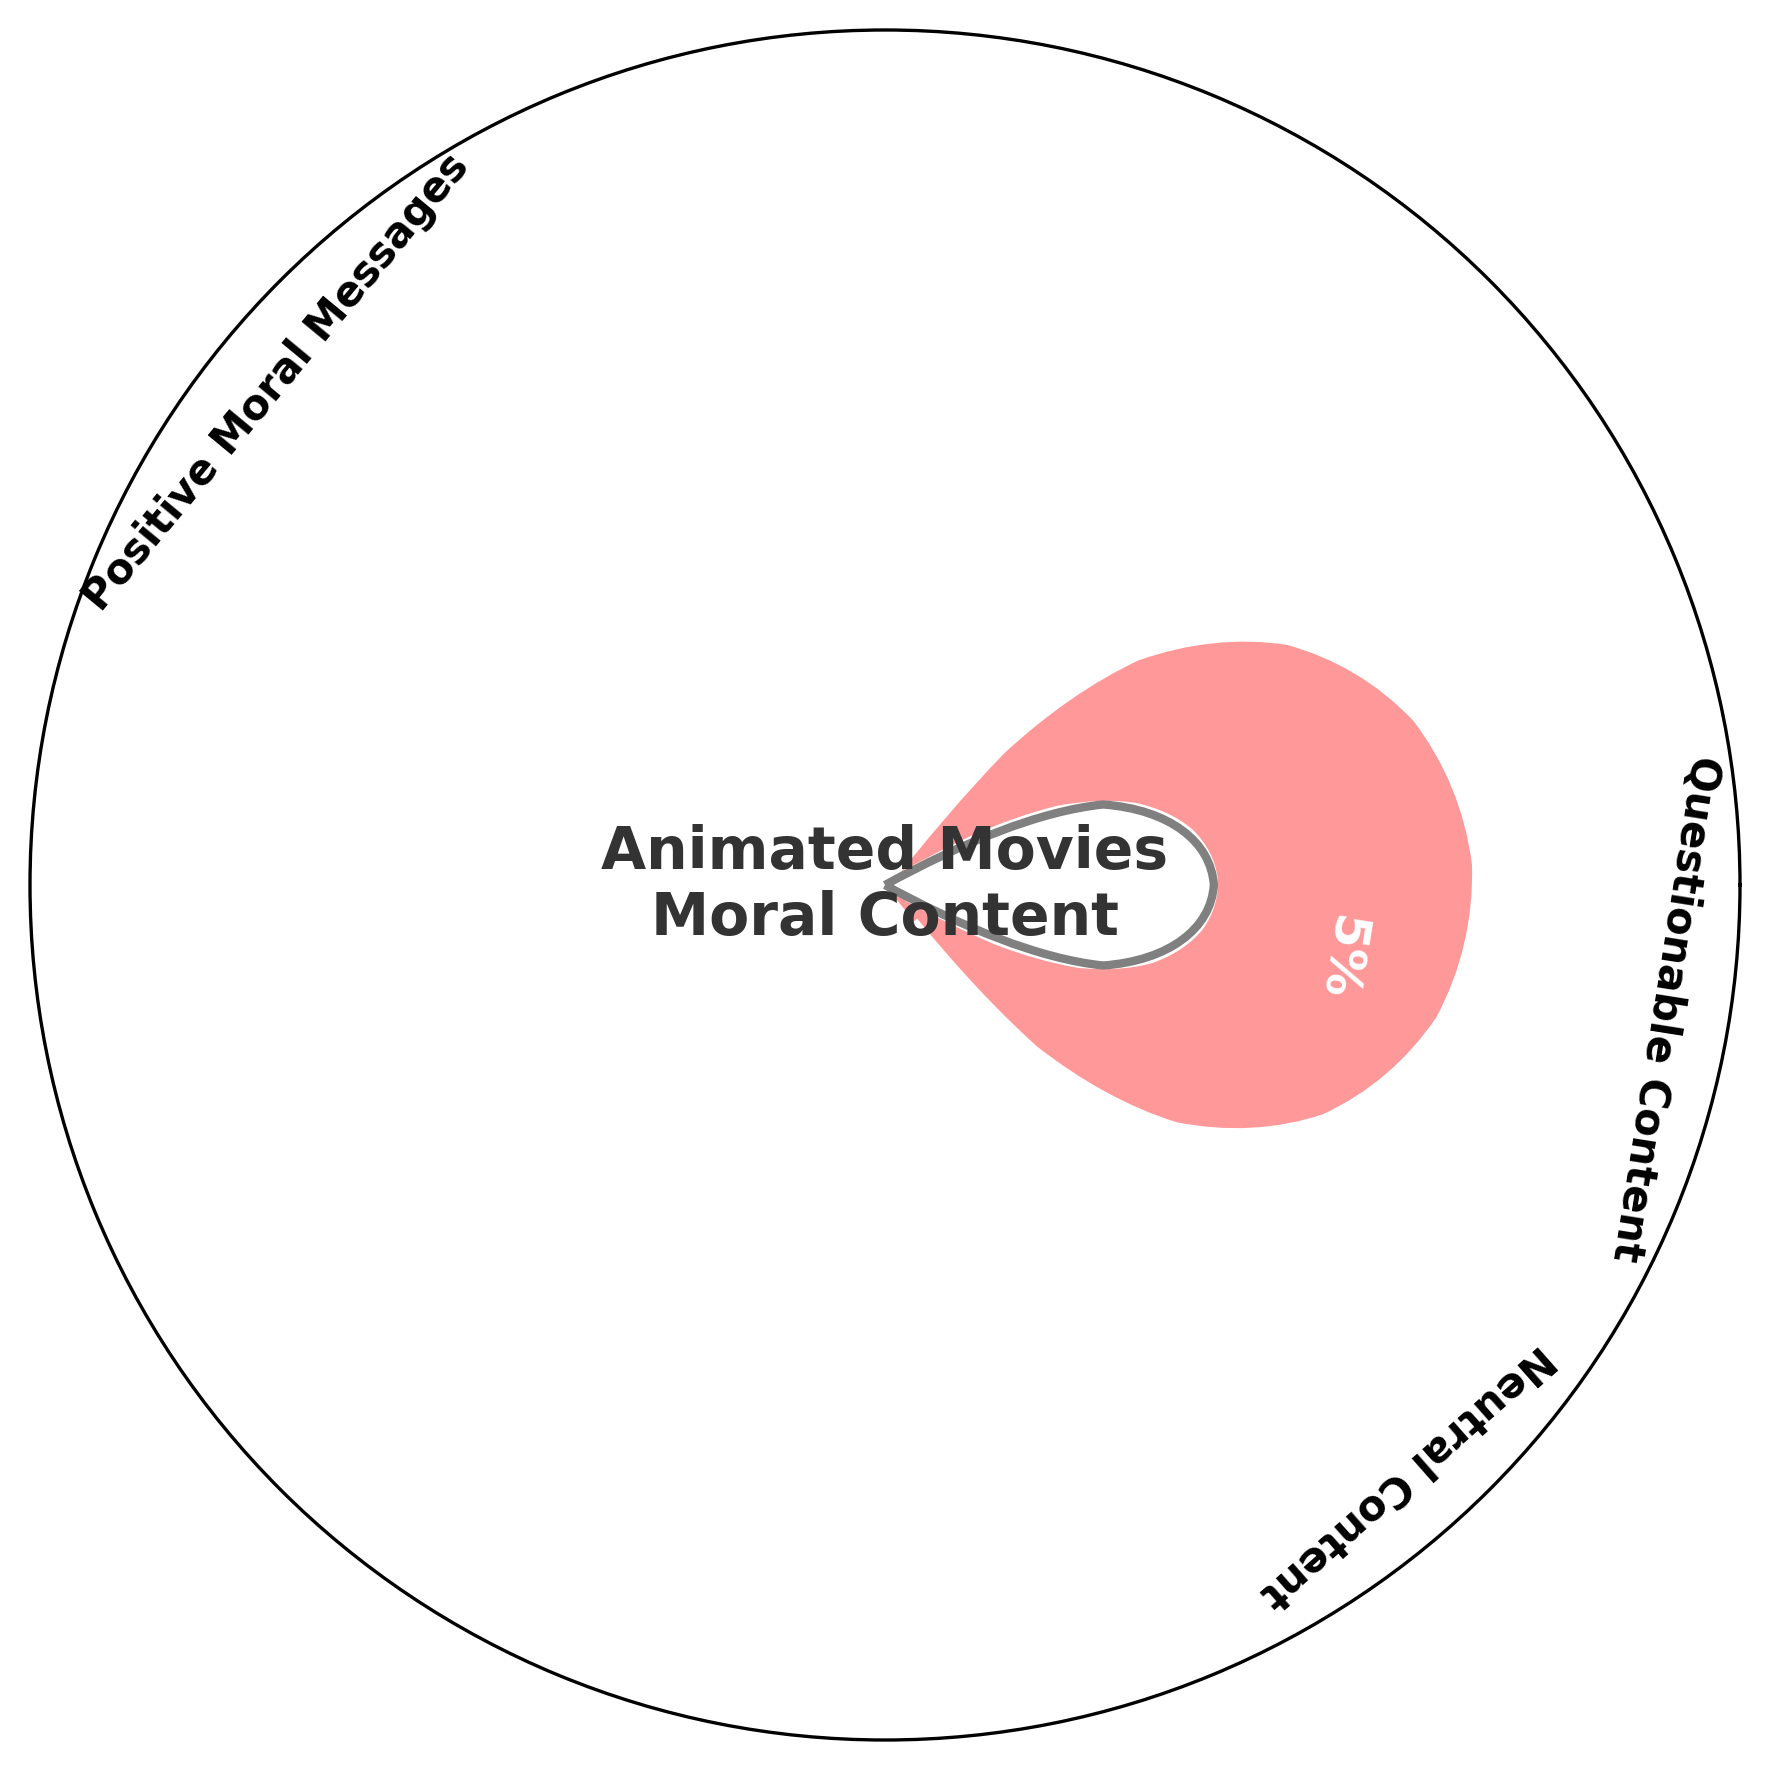What percentage of animated movies released in the last year had positive moral messages? The gauge chart clearly shows that 78% of the animated movies released in the last year had positive moral messages.
Answer: 78% What category had the least percentage of animated movies released in the last year? The gauge chart shows three categories, with the "Questionable Content" segment being the smallest at 5%.
Answer: Questionable Content How do the percentages of animated movies with neutral content and questionable content compare? The gauge chart indicates that neutral content makes up 17%, while questionable content makes up 5%. Comparing these percentages, 17% is greater than 5%.
Answer: Neutral Content > Questionable Content What is the total percentage of animated movies released last year that did not have positive moral messages? To find this, sum the percentages of "Neutral Content" and "Questionable Content" which are 17% and 5% respectively. So, 17% + 5% = 22%.
Answer: 22% What is the angle in the gauge chart for the "Neutral Content" category? The angle for each category can be calculated based on their percentage. For the "Neutral Content" category with 17%, the angle would be 0.17 * 360 degrees = 61.2 degrees.
Answer: 61.2 degrees What is the combined percentage of animated movies with positive moral messages and neutral content? Adding the percentages of "Positive Moral Messages" and "Neutral Content" which are 78% and 17% respectively. So, 78% + 17% = 95%.
Answer: 95% Which category appears directly before the "Positive Moral Messages" category in the chart? The "Questionable Content" category, being the smallest segment at 5%, would appear directly before the larger "Positive Moral Messages" category.
Answer: Questionable Content What is the title of the inner circle in the gauge chart? The title inside the inner circle reads "Animated Movies Moral Content," which summarizes the chart's purpose.
Answer: Animated Movies Moral Content What color represents animated movies with positive moral messages in the chart? The gauge chart uses a specific color palette, where the "Positive Moral Messages" category is represented in a soft red color.
Answer: Soft Red 